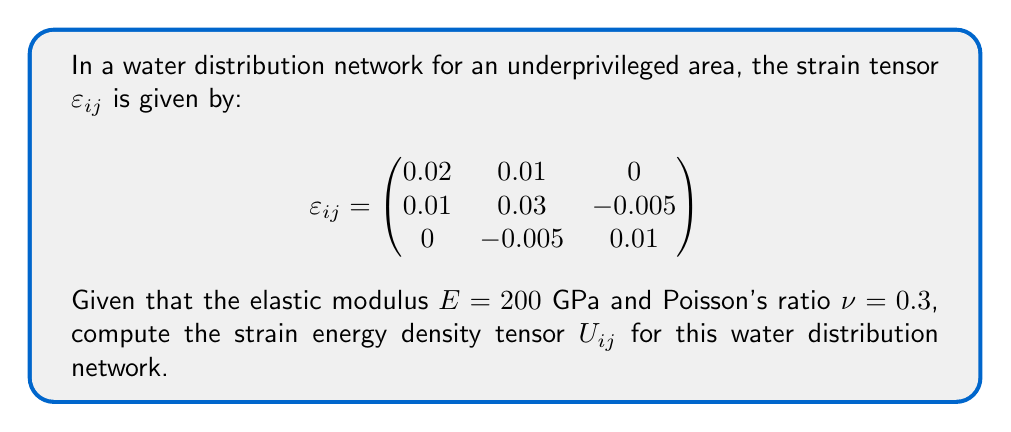Help me with this question. To compute the strain energy density tensor, we'll follow these steps:

1) The strain energy density tensor $U_{ij}$ is given by:

   $$U_{ij} = \frac{1}{2} \sigma_{ij} \varepsilon_{ij}$$

   where $\sigma_{ij}$ is the stress tensor.

2) We need to calculate the stress tensor using Hooke's law for isotropic materials:

   $$\sigma_{ij} = 2\mu\varepsilon_{ij} + \lambda\varepsilon_{kk}\delta_{ij}$$

   where $\mu$ and $\lambda$ are Lamé parameters, and $\varepsilon_{kk}$ is the trace of the strain tensor.

3) Calculate Lamé parameters:
   
   $\mu = \frac{E}{2(1+\nu)} = \frac{200}{2(1+0.3)} = 76.92$ GPa
   
   $\lambda = \frac{E\nu}{(1+\nu)(1-2\nu)} = \frac{200 \cdot 0.3}{(1+0.3)(1-2\cdot0.3)} = 115.38$ GPa

4) Calculate $\varepsilon_{kk}$:
   
   $\varepsilon_{kk} = 0.02 + 0.03 + 0.01 = 0.06$

5) Now, calculate each component of $\sigma_{ij}$:

   $\sigma_{11} = 2(76.92)(0.02) + 115.38(0.06) = 10.38$ GPa
   $\sigma_{22} = 2(76.92)(0.03) + 115.38(0.06) = 11.54$ GPa
   $\sigma_{33} = 2(76.92)(0.01) + 115.38(0.06) = 8.46$ GPa
   $\sigma_{12} = \sigma_{21} = 2(76.92)(0.01) = 1.54$ GPa
   $\sigma_{23} = \sigma_{32} = 2(76.92)(-0.005) = -0.77$ GPa
   $\sigma_{13} = \sigma_{31} = 2(76.92)(0) = 0$ GPa

6) Now we can calculate each component of $U_{ij}$:

   $U_{11} = \frac{1}{2}(10.38)(0.02) = 0.1038$ GPa
   $U_{22} = \frac{1}{2}(11.54)(0.03) = 0.1731$ GPa
   $U_{33} = \frac{1}{2}(8.46)(0.01) = 0.0423$ GPa
   $U_{12} = U_{21} = \frac{1}{2}(1.54)(0.01) = 0.0077$ GPa
   $U_{23} = U_{32} = \frac{1}{2}(-0.77)(-0.005) = 0.001925$ GPa
   $U_{13} = U_{31} = \frac{1}{2}(0)(0) = 0$ GPa

7) The strain energy density tensor is:

   $$U_{ij} = \begin{pmatrix}
   0.1038 & 0.0077 & 0 \\
   0.0077 & 0.1731 & 0.001925 \\
   0 & 0.001925 & 0.0423
   \end{pmatrix}$$ GPa
Answer: $$U_{ij} = \begin{pmatrix}
0.1038 & 0.0077 & 0 \\
0.0077 & 0.1731 & 0.001925 \\
0 & 0.001925 & 0.0423
\end{pmatrix}$$ GPa 